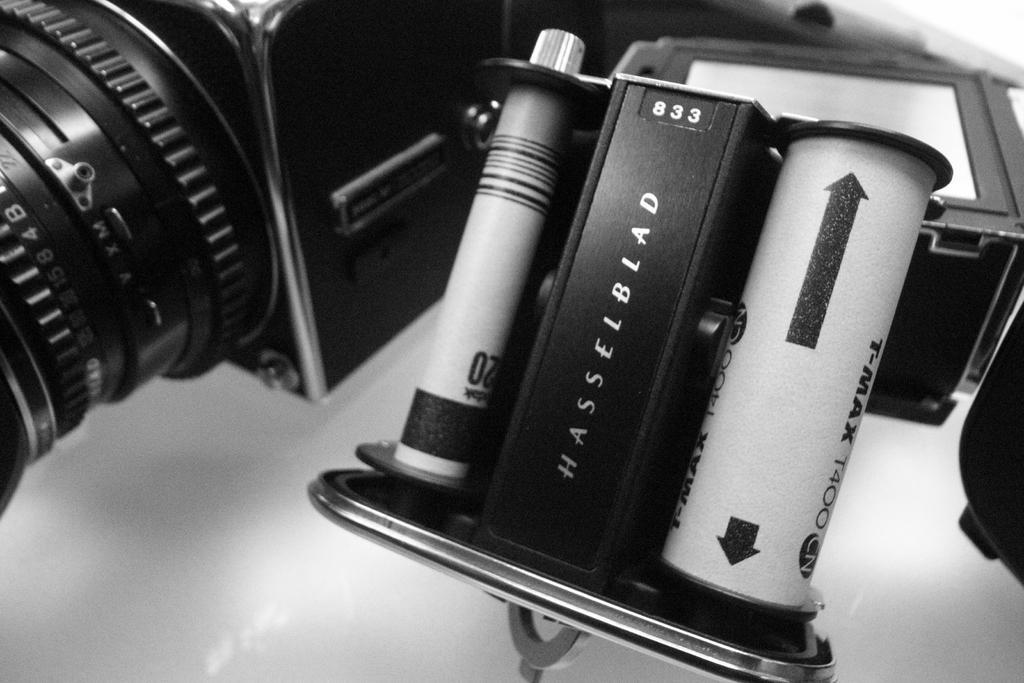In one or two sentences, can you explain what this image depicts? In this image I can see the black color camera and there is a something written on it. And there is a white background. 